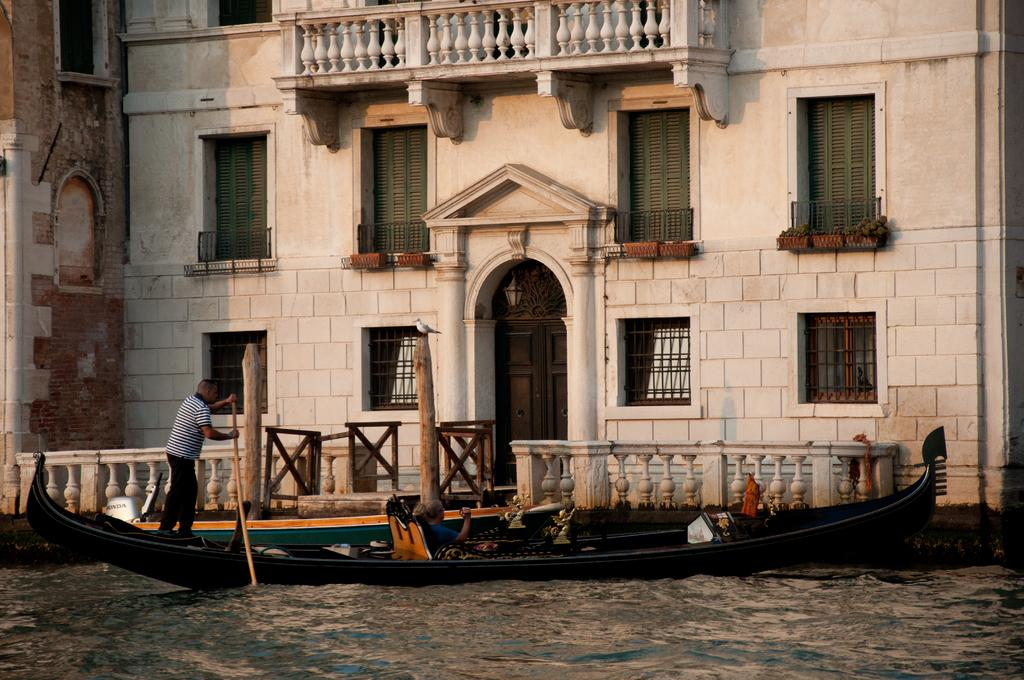What type of structure is visible in the image? There is a building in the image. Where is the building situated? The building is located in front of a lake. How many people are in the image? There are two persons in the image. What are the two persons doing in the image? The two persons are on a boat. What is the condition of the boat in the image? The boat is floating on the water. What type of cactus can be seen growing on the building in the image? There is no cactus visible on the building in the image. 